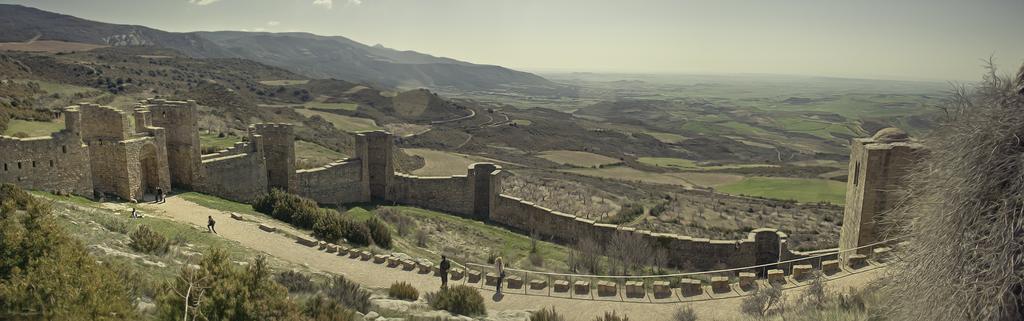How would you summarize this image in a sentence or two? In this image few persons are standing on the path having fence. A person is sitting on the grassland having plants and trees. There is a wall at the middle of image. Behind there is hill. Right side there is grass on the land. Top of image there is sky. 